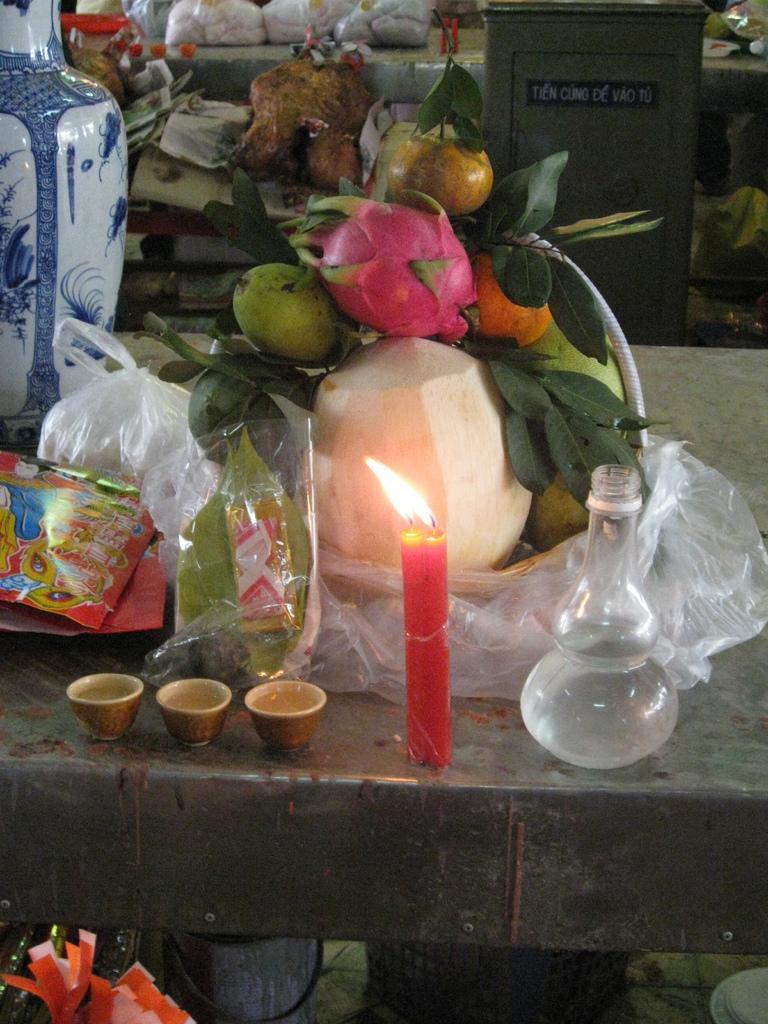Could you give a brief overview of what you see in this image? In this image in the front there is an object which is pink in colour and in the center there is a table, on the table there are cups, packets and there is a basket full of fruits. In the background there are objects which are black and white in colour. 